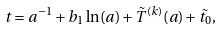<formula> <loc_0><loc_0><loc_500><loc_500>t = a ^ { - 1 } + b _ { 1 } \ln ( a ) + { \tilde { T } } ^ { ( k ) } ( a ) + \tilde { t _ { 0 } } ,</formula> 